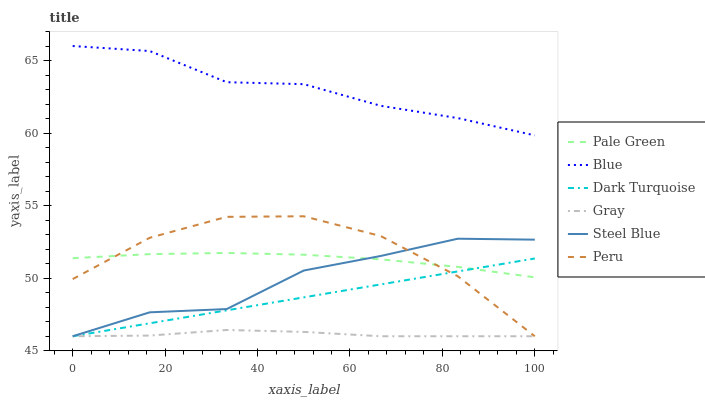Does Dark Turquoise have the minimum area under the curve?
Answer yes or no. No. Does Dark Turquoise have the maximum area under the curve?
Answer yes or no. No. Is Gray the smoothest?
Answer yes or no. No. Is Gray the roughest?
Answer yes or no. No. Does Pale Green have the lowest value?
Answer yes or no. No. Does Dark Turquoise have the highest value?
Answer yes or no. No. Is Steel Blue less than Blue?
Answer yes or no. Yes. Is Blue greater than Steel Blue?
Answer yes or no. Yes. Does Steel Blue intersect Blue?
Answer yes or no. No. 